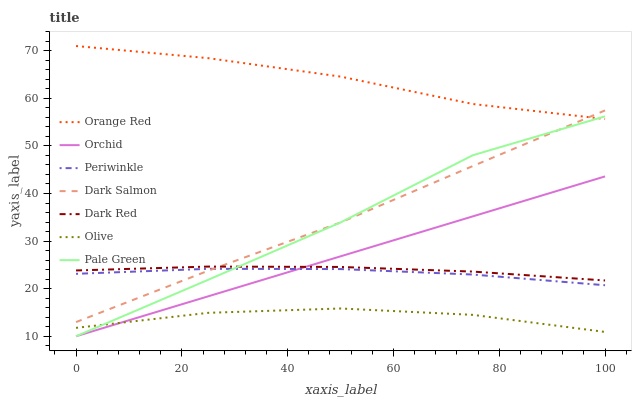Does Olive have the minimum area under the curve?
Answer yes or no. Yes. Does Orange Red have the maximum area under the curve?
Answer yes or no. Yes. Does Dark Salmon have the minimum area under the curve?
Answer yes or no. No. Does Dark Salmon have the maximum area under the curve?
Answer yes or no. No. Is Orchid the smoothest?
Answer yes or no. Yes. Is Pale Green the roughest?
Answer yes or no. Yes. Is Dark Salmon the smoothest?
Answer yes or no. No. Is Dark Salmon the roughest?
Answer yes or no. No. Does Pale Green have the lowest value?
Answer yes or no. Yes. Does Dark Salmon have the lowest value?
Answer yes or no. No. Does Orange Red have the highest value?
Answer yes or no. Yes. Does Dark Salmon have the highest value?
Answer yes or no. No. Is Dark Red less than Orange Red?
Answer yes or no. Yes. Is Dark Salmon greater than Orchid?
Answer yes or no. Yes. Does Dark Salmon intersect Orange Red?
Answer yes or no. Yes. Is Dark Salmon less than Orange Red?
Answer yes or no. No. Is Dark Salmon greater than Orange Red?
Answer yes or no. No. Does Dark Red intersect Orange Red?
Answer yes or no. No. 